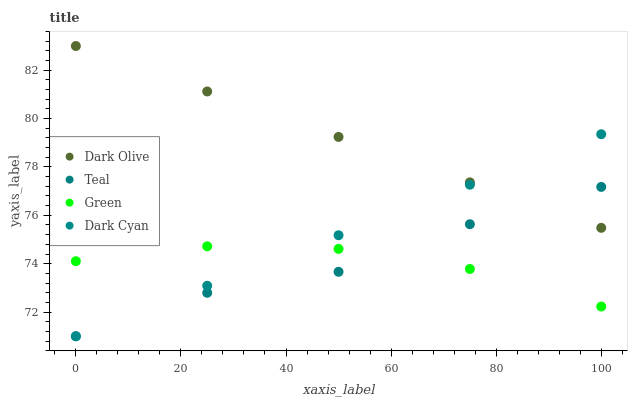Does Teal have the minimum area under the curve?
Answer yes or no. Yes. Does Dark Olive have the maximum area under the curve?
Answer yes or no. Yes. Does Green have the minimum area under the curve?
Answer yes or no. No. Does Green have the maximum area under the curve?
Answer yes or no. No. Is Dark Cyan the smoothest?
Answer yes or no. Yes. Is Teal the roughest?
Answer yes or no. Yes. Is Dark Olive the smoothest?
Answer yes or no. No. Is Dark Olive the roughest?
Answer yes or no. No. Does Dark Cyan have the lowest value?
Answer yes or no. Yes. Does Green have the lowest value?
Answer yes or no. No. Does Dark Olive have the highest value?
Answer yes or no. Yes. Does Green have the highest value?
Answer yes or no. No. Is Green less than Dark Olive?
Answer yes or no. Yes. Is Dark Olive greater than Green?
Answer yes or no. Yes. Does Dark Cyan intersect Teal?
Answer yes or no. Yes. Is Dark Cyan less than Teal?
Answer yes or no. No. Is Dark Cyan greater than Teal?
Answer yes or no. No. Does Green intersect Dark Olive?
Answer yes or no. No. 